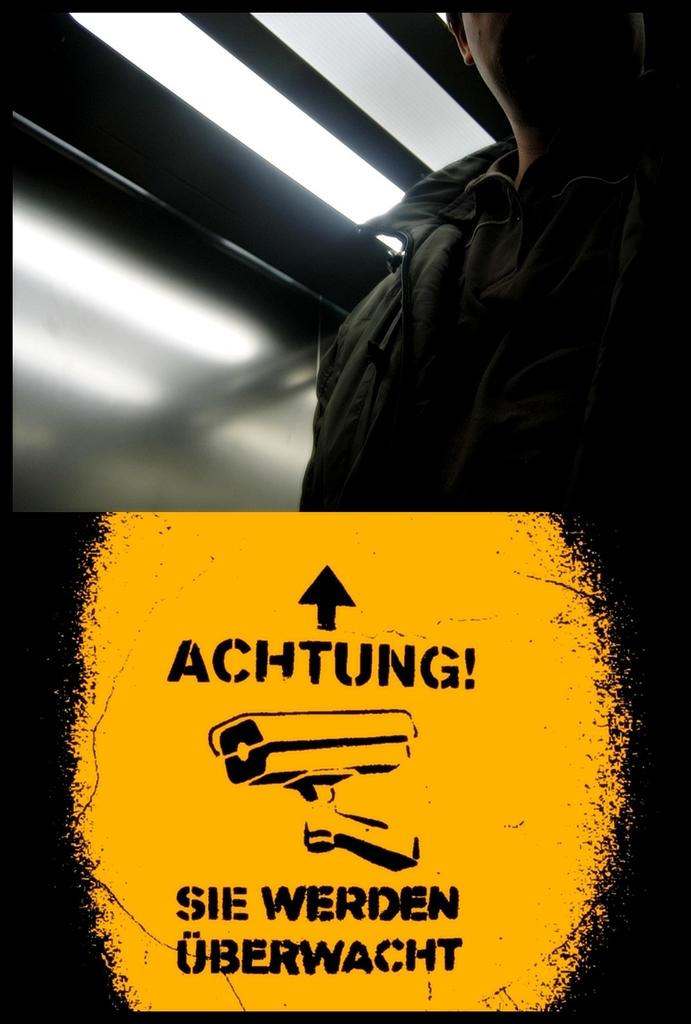Who is present in the image? There is a man in the image. What is the man wearing? The man is wearing a jacket. What can be seen at the bottom of the image? There is a poster at the bottom of the image. What is depicted on the poster? The poster shows a camera. What type of lighting is visible at the top of the image? There is a tube-light at the top of the image. What type of treatment is the man receiving for his stomach ache in the image? There is no indication in the image that the man is experiencing a stomach ache or receiving any treatment. 